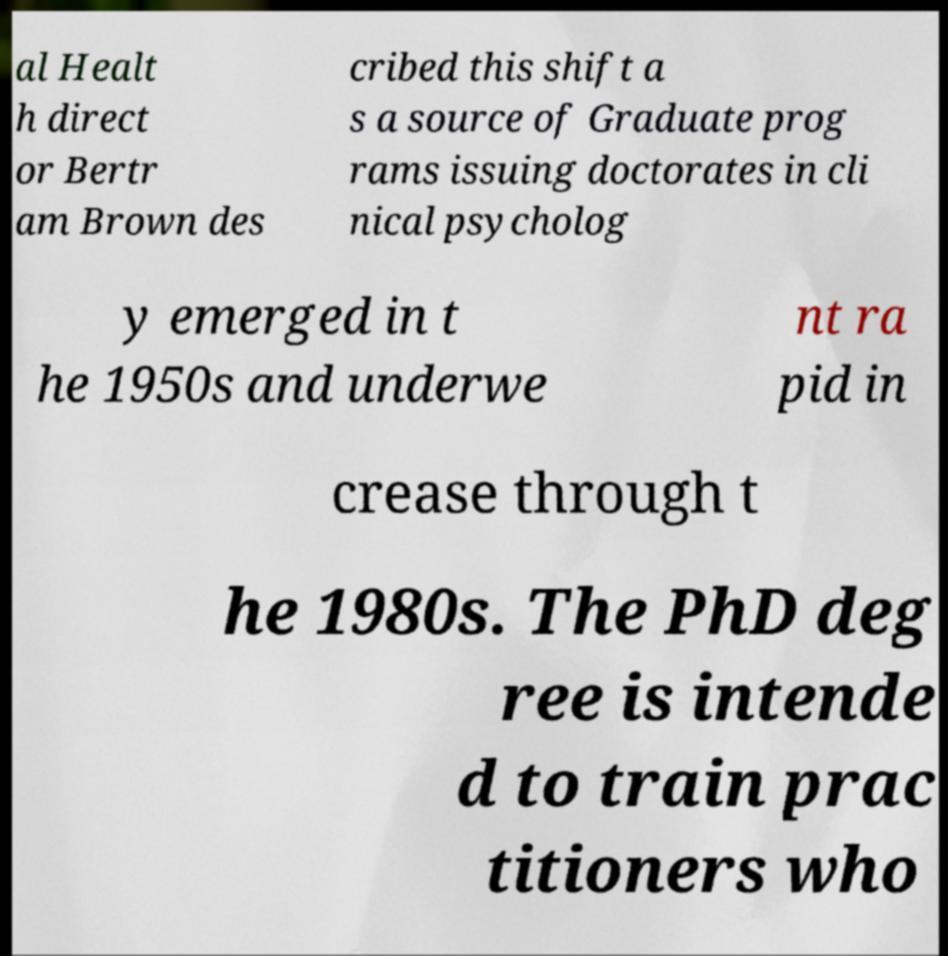I need the written content from this picture converted into text. Can you do that? al Healt h direct or Bertr am Brown des cribed this shift a s a source of Graduate prog rams issuing doctorates in cli nical psycholog y emerged in t he 1950s and underwe nt ra pid in crease through t he 1980s. The PhD deg ree is intende d to train prac titioners who 